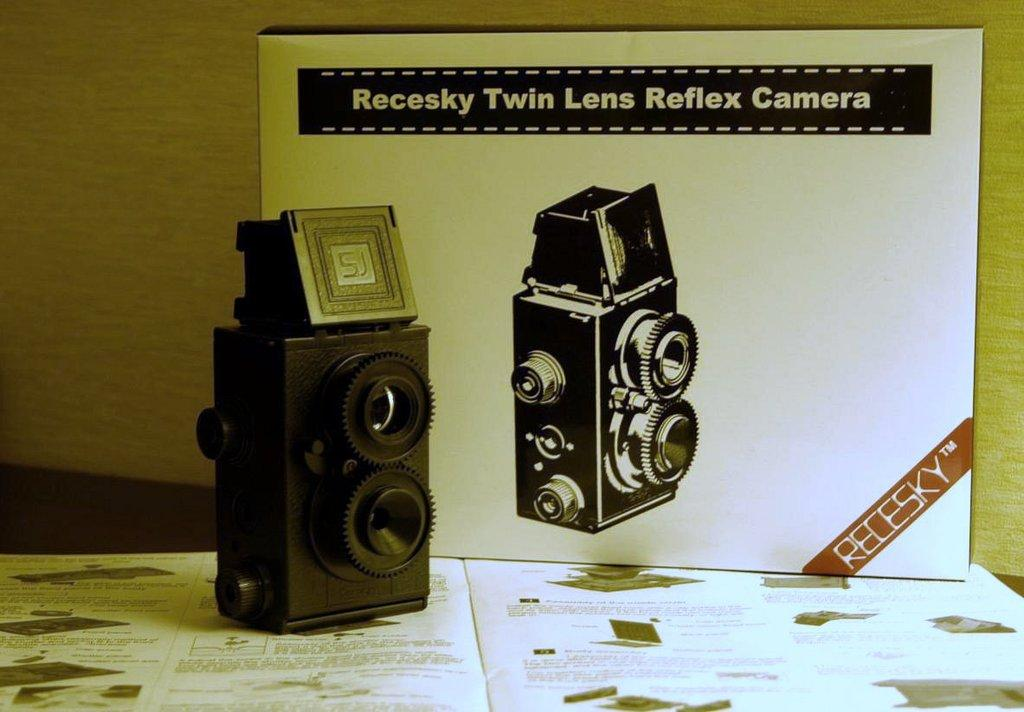What object is the main focus of the image? There is a camera in the image. What other object can be seen at the bottom of the image? There is a book at the bottom of the image. What can be seen in the background of the image? There is a board and a wall in the background of the image. What is written or depicted on the board? There is text on the board, and there is a picture of a camera. How many lizards are crawling on the camera in the image? There are no lizards present in the image. What effect does the camera have on the debt in the image? There is no mention of debt in the image, and the camera is not shown to have any effect on it. 